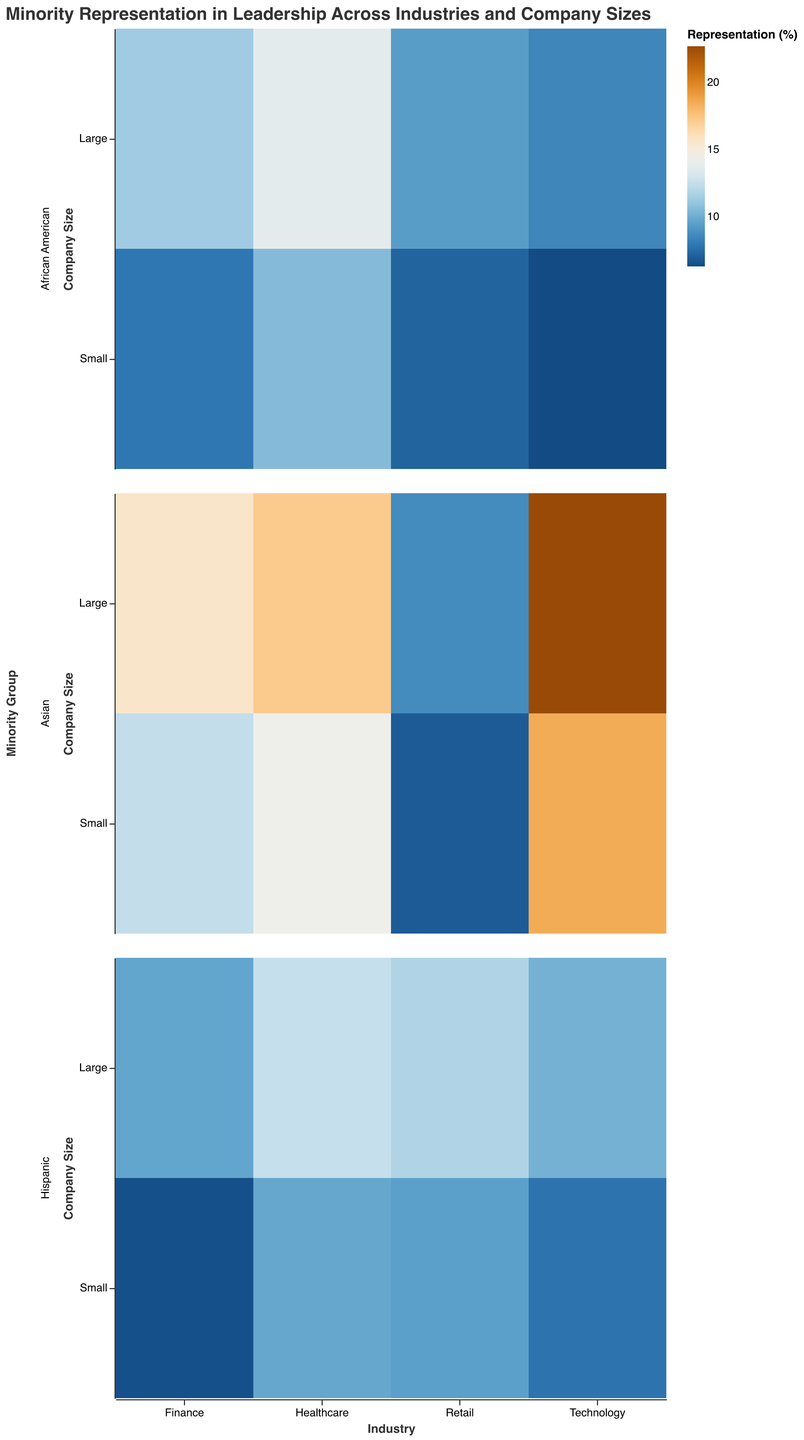What is the title of the figure? The title is displayed at the top of the figure and reads "Minority Representation in Leadership Across Industries and Company Sizes"
Answer: "Minority Representation in Leadership Across Industries and Company Sizes" Which minority group has the highest representation percentage in large technology companies? For large technology companies, the color intensity is compared among African American (8.5%), Hispanic (10.2%), and Asian (22.7%). The Asian group has the highest representation.
Answer: Asian What is the average representation percentage of African Americans in small companies across all industries? To find the average, sum the percentages for African Americans in small companies across Technology (6.3), Finance (7.9), Healthcare (10.6), and Retail (7.2), then divide by 4. (6.3 + 7.9 + 10.6 + 7.2) / 4 = 8
Answer: 8 Among the large companies, which industry shows the highest representation percentage for Hispanics? Compare the percentage for Hispanics in large companies across Technology (10.2%), Finance (9.7%), Healthcare (12.5%), and Retail (11.8%). Healthcare has the highest percentage at 12.5%.
Answer: Healthcare Is representation of Asian minority groups generally higher in large or small companies across industries? Examine the color for Asian representation in large and small company groups across all industries. Most industries show higher representation in large companies, such as Technology (large 22.7%, small 18.5%), Finance (large 15.6%, small 12.4%), etc.
Answer: Large Which industry has the lowest representation percentage of Hispanic minorities in small companies? Compare the Hispanic representation in small companies across Technology (7.8%), Finance (6.5%), Healthcare (9.8%), and Retail (9.5%). Finance has the lowest at 6.5%.
Answer: Finance What is the difference in representation percentage of African Americans in large and small healthcare companies? Subtract the representation percentage in small healthcare (10.6%) from that in large healthcare (13.8%), which is 13.8 - 10.6 = 3.2
Answer: 3.2 Are there any industries where the representation percentage of African Americans in small companies is higher compared to large companies? Compare African American representation across industries for large and small companies: Technology (6.3 vs 8.5), Finance (7.9 vs 11.3), Healthcare (10.6 vs 13.8), Retail (7.2 vs 9.4). In all cases, large companies have higher representation than small companies.
Answer: No What is the representation percentage range for Asian minority groups in retail companies of both sizes? From the visual legend and color gradient for Retail, Asian representation in large companies is 8.7% and in small companies is 6.9%. Calculate the range: 8.7 - 6.9 = 1.8
Answer: 1.8 How does the representation of Hispanic minorities in large finance companies compare to small healthcare companies? Compare the percentages directly: Hispanic representation in large finance is 9.7%, while in small healthcare it is 9.8%. 9.8% is slightly higher than 9.7%.
Answer: Slightly higher in small healthcare 